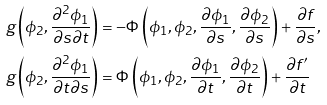<formula> <loc_0><loc_0><loc_500><loc_500>g \left ( \phi _ { 2 } , \frac { \partial ^ { 2 } \phi _ { 1 } } { \partial s \partial t } \right ) & = - \Phi \left ( \phi _ { 1 } , \phi _ { 2 } , \frac { \partial \phi _ { 1 } } { \partial s } , \frac { \partial \phi _ { 2 } } { \partial s } \right ) + \frac { \partial f } { \partial s } , \\ g \left ( \phi _ { 2 } , \frac { \partial ^ { 2 } \phi _ { 1 } } { \partial t \partial s } \right ) & = \Phi \left ( \phi _ { 1 } , \phi _ { 2 } , \frac { \partial \phi _ { 1 } } { \partial t } , \frac { \partial \phi _ { 2 } } { \partial t } \right ) + \frac { \partial f ^ { \prime } } { \partial t }</formula> 